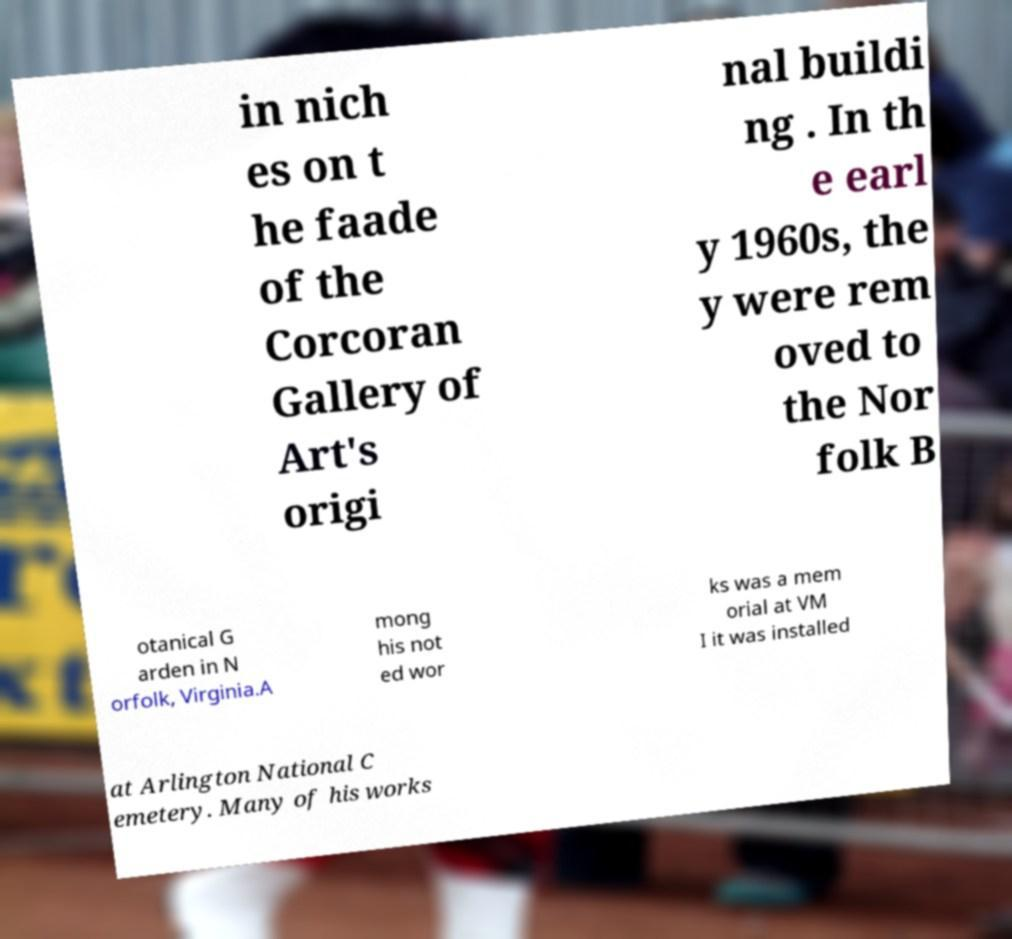Could you extract and type out the text from this image? in nich es on t he faade of the Corcoran Gallery of Art's origi nal buildi ng . In th e earl y 1960s, the y were rem oved to the Nor folk B otanical G arden in N orfolk, Virginia.A mong his not ed wor ks was a mem orial at VM I it was installed at Arlington National C emetery. Many of his works 